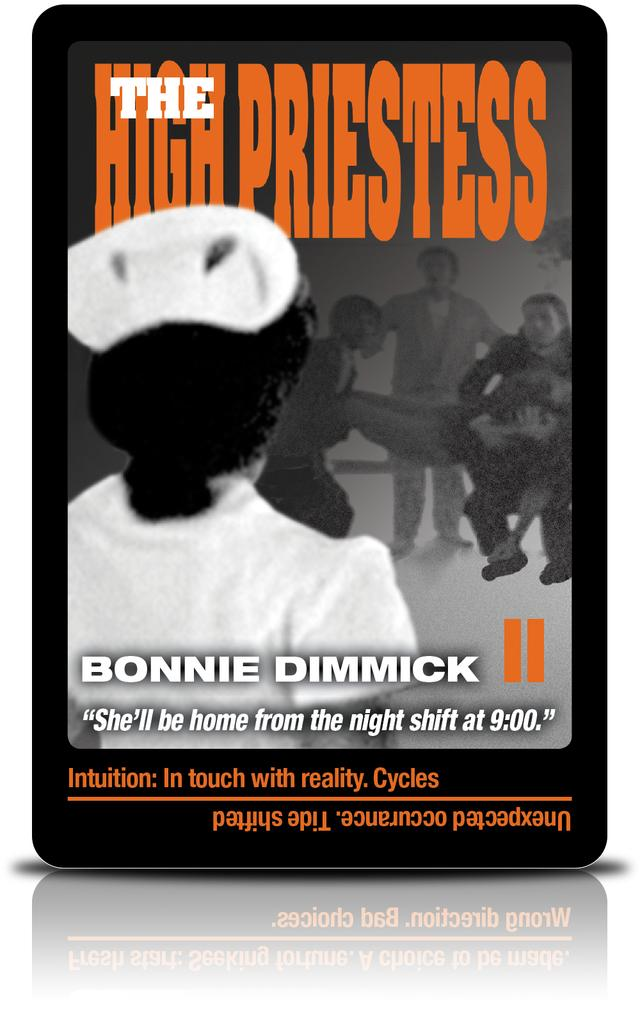What type of visual is the image? The image is a poster. What can be found on the poster? There are letters and people depicted on the poster. Can you describe the reflection of the poster? There is a reflection of the poster. What type of game is being played by the people in the poster? There is no game being played by the people in the poster; they are simply depicted as part of the poster's design. What material is the poster made of, such as copper? The material of the poster is not mentioned in the provided facts, so it cannot be determined whether it is made of copper or any other material. 